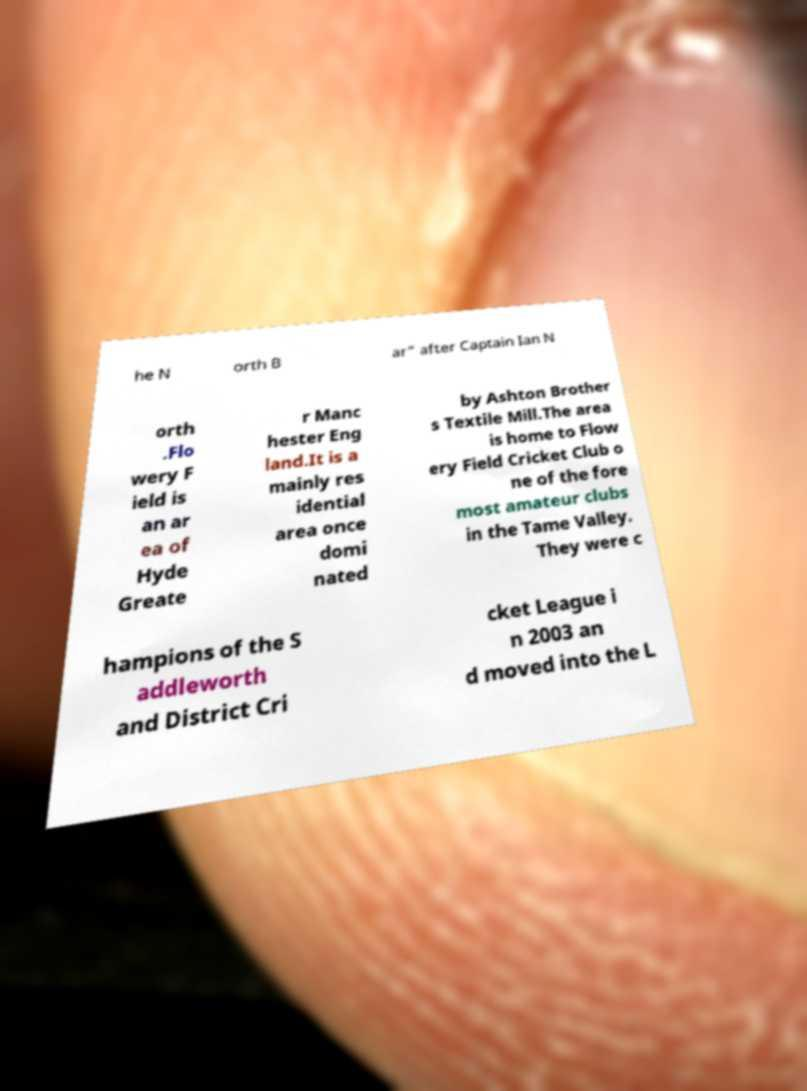I need the written content from this picture converted into text. Can you do that? he N orth B ar" after Captain Ian N orth .Flo wery F ield is an ar ea of Hyde Greate r Manc hester Eng land.It is a mainly res idential area once domi nated by Ashton Brother s Textile Mill.The area is home to Flow ery Field Cricket Club o ne of the fore most amateur clubs in the Tame Valley. They were c hampions of the S addleworth and District Cri cket League i n 2003 an d moved into the L 